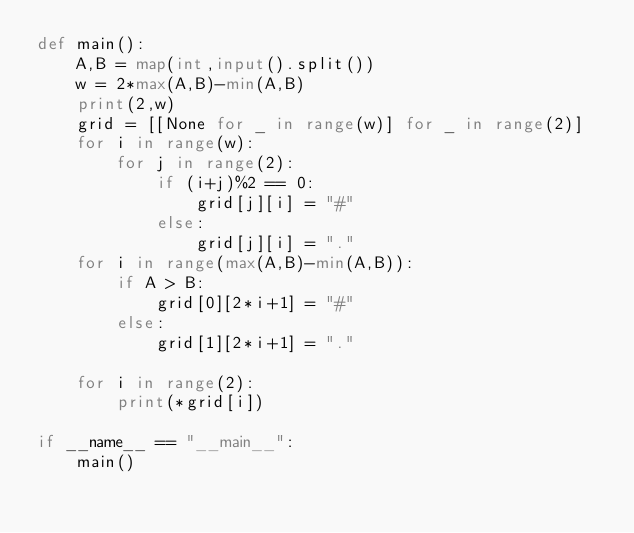<code> <loc_0><loc_0><loc_500><loc_500><_Python_>def main():
    A,B = map(int,input().split())
    w = 2*max(A,B)-min(A,B)
    print(2,w)
    grid = [[None for _ in range(w)] for _ in range(2)]
    for i in range(w):
        for j in range(2):
            if (i+j)%2 == 0:
                grid[j][i] = "#"
            else:
                grid[j][i] = "."
    for i in range(max(A,B)-min(A,B)):
        if A > B:
            grid[0][2*i+1] = "#"
        else:
            grid[1][2*i+1] = "."

    for i in range(2):
        print(*grid[i])

if __name__ == "__main__":
    main()</code> 